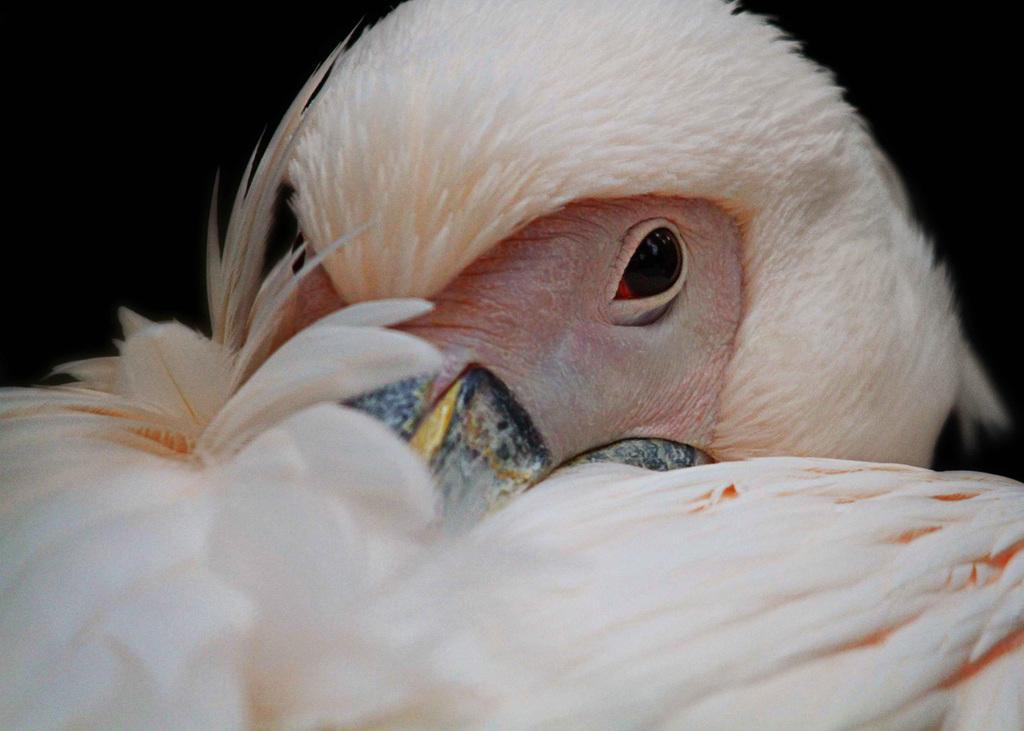Describe this image in one or two sentences. In the center of the image we can see a bird. 